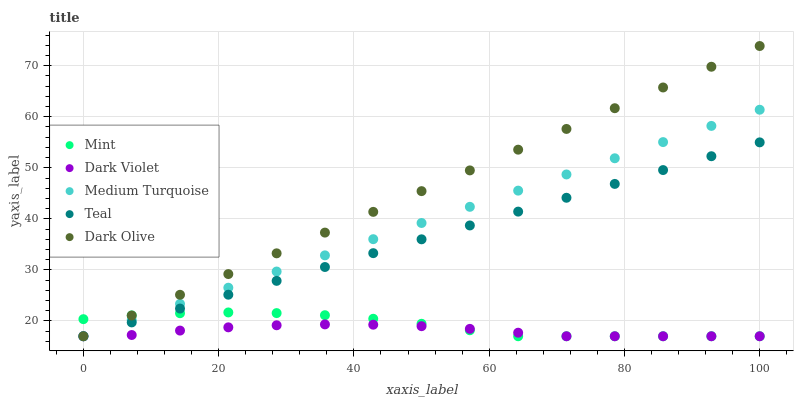Does Dark Violet have the minimum area under the curve?
Answer yes or no. Yes. Does Dark Olive have the maximum area under the curve?
Answer yes or no. Yes. Does Mint have the minimum area under the curve?
Answer yes or no. No. Does Mint have the maximum area under the curve?
Answer yes or no. No. Is Dark Olive the smoothest?
Answer yes or no. Yes. Is Mint the roughest?
Answer yes or no. Yes. Is Mint the smoothest?
Answer yes or no. No. Is Dark Olive the roughest?
Answer yes or no. No. Does Teal have the lowest value?
Answer yes or no. Yes. Does Dark Olive have the highest value?
Answer yes or no. Yes. Does Mint have the highest value?
Answer yes or no. No. Does Teal intersect Dark Violet?
Answer yes or no. Yes. Is Teal less than Dark Violet?
Answer yes or no. No. Is Teal greater than Dark Violet?
Answer yes or no. No. 